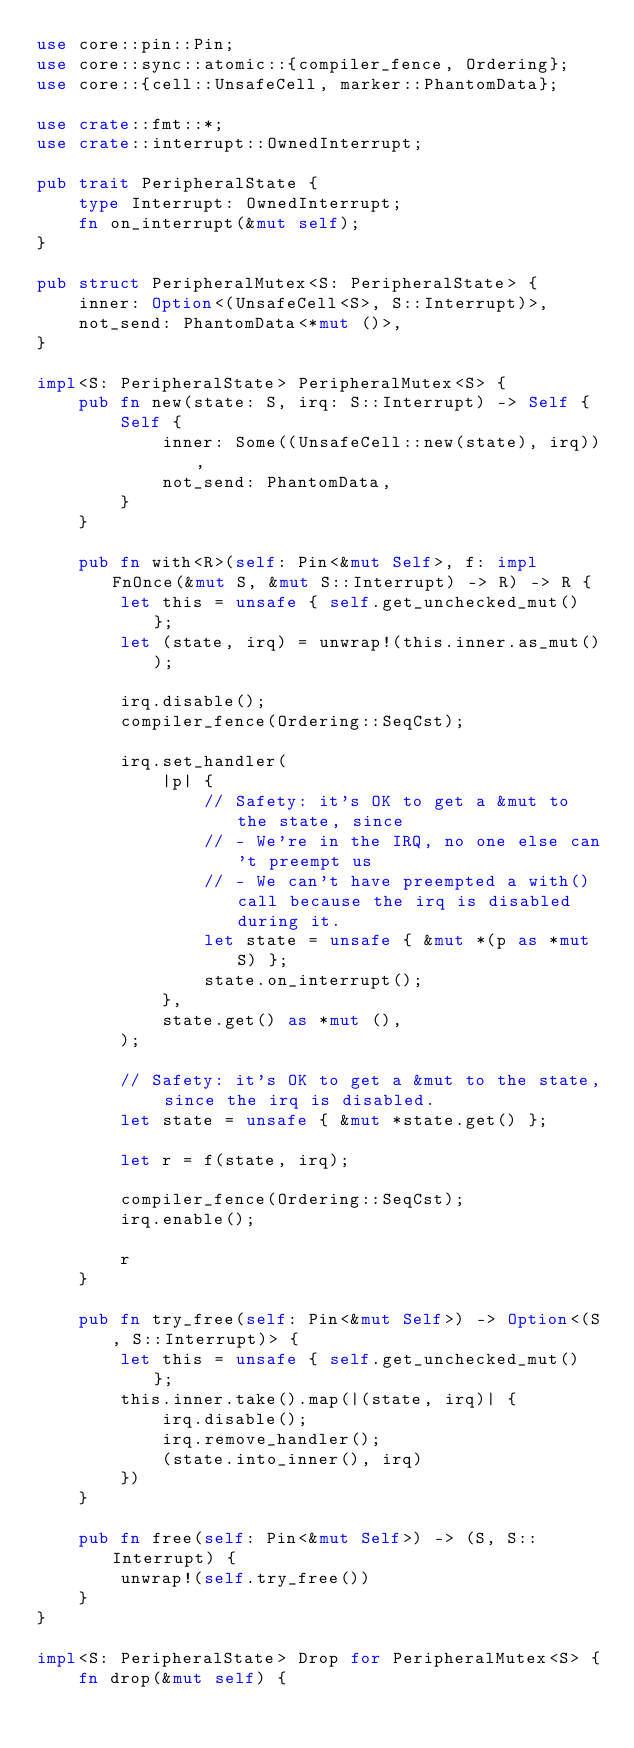<code> <loc_0><loc_0><loc_500><loc_500><_Rust_>use core::pin::Pin;
use core::sync::atomic::{compiler_fence, Ordering};
use core::{cell::UnsafeCell, marker::PhantomData};

use crate::fmt::*;
use crate::interrupt::OwnedInterrupt;

pub trait PeripheralState {
    type Interrupt: OwnedInterrupt;
    fn on_interrupt(&mut self);
}

pub struct PeripheralMutex<S: PeripheralState> {
    inner: Option<(UnsafeCell<S>, S::Interrupt)>,
    not_send: PhantomData<*mut ()>,
}

impl<S: PeripheralState> PeripheralMutex<S> {
    pub fn new(state: S, irq: S::Interrupt) -> Self {
        Self {
            inner: Some((UnsafeCell::new(state), irq)),
            not_send: PhantomData,
        }
    }

    pub fn with<R>(self: Pin<&mut Self>, f: impl FnOnce(&mut S, &mut S::Interrupt) -> R) -> R {
        let this = unsafe { self.get_unchecked_mut() };
        let (state, irq) = unwrap!(this.inner.as_mut());

        irq.disable();
        compiler_fence(Ordering::SeqCst);

        irq.set_handler(
            |p| {
                // Safety: it's OK to get a &mut to the state, since
                // - We're in the IRQ, no one else can't preempt us
                // - We can't have preempted a with() call because the irq is disabled during it.
                let state = unsafe { &mut *(p as *mut S) };
                state.on_interrupt();
            },
            state.get() as *mut (),
        );

        // Safety: it's OK to get a &mut to the state, since the irq is disabled.
        let state = unsafe { &mut *state.get() };

        let r = f(state, irq);

        compiler_fence(Ordering::SeqCst);
        irq.enable();

        r
    }

    pub fn try_free(self: Pin<&mut Self>) -> Option<(S, S::Interrupt)> {
        let this = unsafe { self.get_unchecked_mut() };
        this.inner.take().map(|(state, irq)| {
            irq.disable();
            irq.remove_handler();
            (state.into_inner(), irq)
        })
    }

    pub fn free(self: Pin<&mut Self>) -> (S, S::Interrupt) {
        unwrap!(self.try_free())
    }
}

impl<S: PeripheralState> Drop for PeripheralMutex<S> {
    fn drop(&mut self) {</code> 